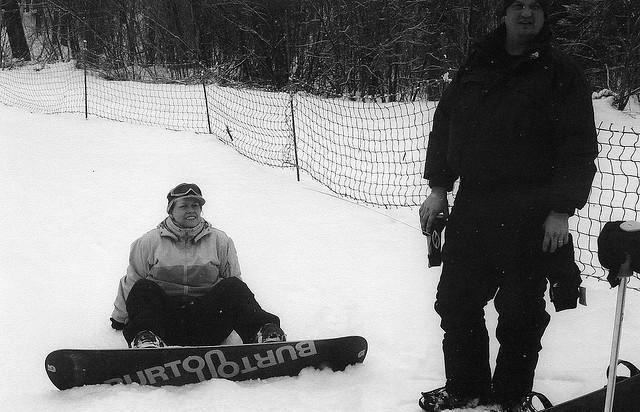How many people are there?
Give a very brief answer. 2. How many chairs are there?
Give a very brief answer. 0. 